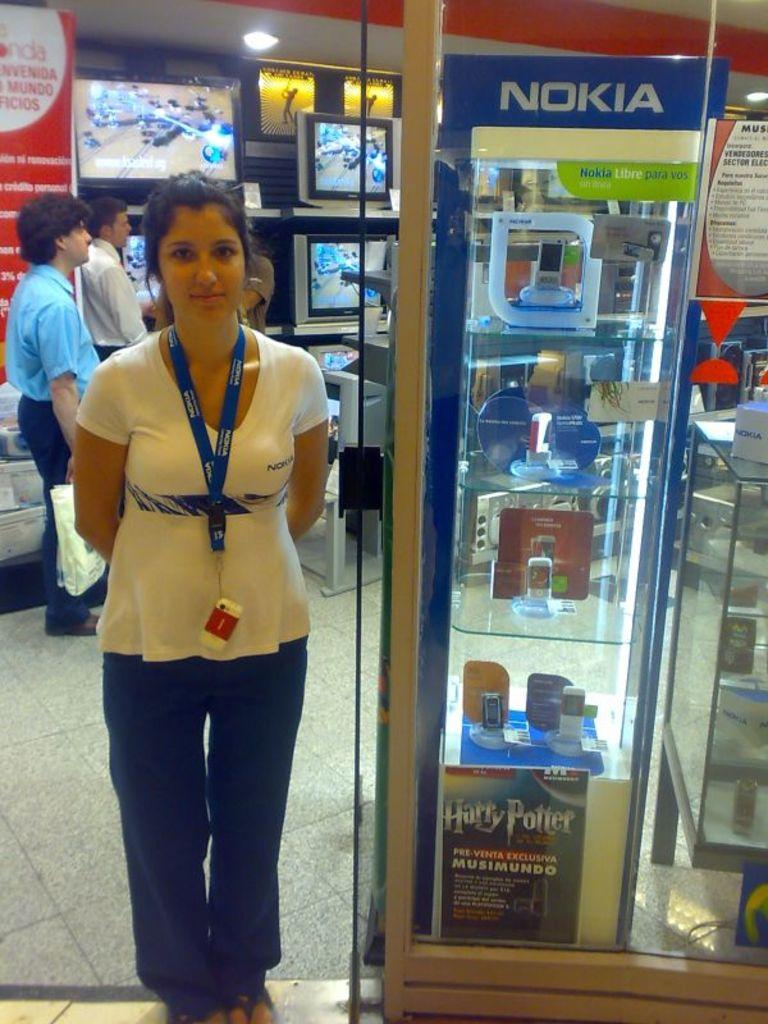Who is present in the image? There is a woman in the image. What is the woman doing in the image? The woman is standing beside a mobile stand and taking pictures. What can be seen in the background of the image? There are televisions placed at the back side of the image. Are there any other people in the image besides the woman? Yes, there are people standing in the image. What type of weather can be seen in the image? There is no indication of weather in the image, as it is an indoor scene. 